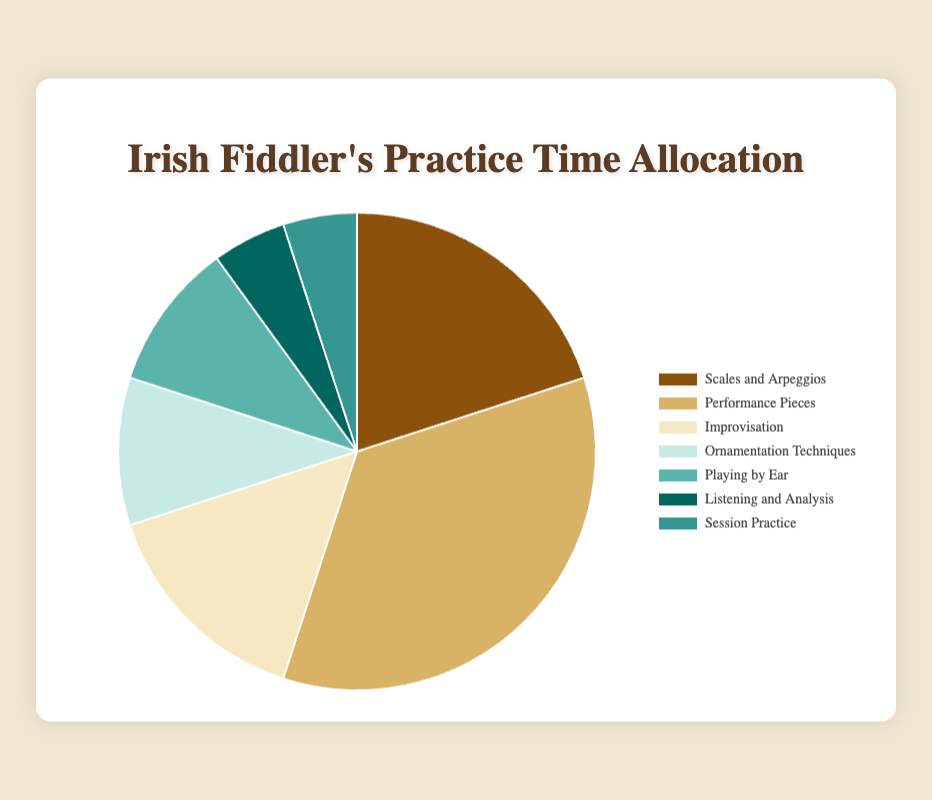What percentage of practice time is allocated to "Improvisation" and "Ornamentation Techniques" combined? To find the combined practice time, add the percentage allocated to "Improvisation" (15%) and "Ornamentation Techniques" (10%). This is 15% + 10% = 25%.
Answer: 25% Which component has the highest allocation of practice time? Look at the percentages for each component and identify the one with the highest value. "Performance Pieces" has the highest allocation at 35%.
Answer: Performance Pieces Is the practice time allocated to "Improvisation" more than that allocated to "Ornamentation Techniques"? Compare the percentages for "Improvisation" (15%) and "Ornamentation Techniques" (10%). Since 15% is greater than 10%, "Improvisation" has more practice time.
Answer: Yes What is the difference in practice time between "Scales and Arpeggios" and "Performance Pieces"? Subtract the percentage for "Scales and Arpeggios" (20%) from that for "Performance Pieces" (35%). This is 35% - 20% = 15%.
Answer: 15% Which components make up a total of 30% of practice time? Find combinations of components that add up to 30%. "Ornamentation Techniques" (10%), "Playing by Ear" (10%), and "Listening and Analysis" (5%) together add up to 30%. Alternatively, "Ornamentation Techniques" (10%) and "Improvisation" (15%) also sum to 30%.
Answer: Ornamentation Techniques, Playing by Ear, Listening and Analysis OR Ornamentation Techniques, Improvisation How much more practice time is allocated to "Playing by Ear" compared to "Listening and Analysis"? Subtract the percentage for "Listening and Analysis" (5%) from that for "Playing by Ear" (10%). This is 10% - 5% = 5%.
Answer: 5% What are the colors representing "Improvisation" and "Session Practice" on the pie chart? Based on the given data, "Improvisation" is represented by a certain color, and "Session Practice" by another. From the script, "Improvisation" is in a certain color, and "Session Practice" is in another. Describe the colors listed next to each.
Answer: Improvisation is light greenish-blue, Session Practice is teal If 50% of the total practice time must be spent on "Scales and Arpeggios" and "Performance Pieces", how much more time needs to be allocated to these components? Currently, "Scales and Arpeggios" (20%) and "Performance Pieces" (35%) together sum to 55%. Therefore, no additional time needs to be allocated as the combined total already exceeds 50%.
Answer: None; already exceeds 50% How does the time allocated to "Listening and Analysis" compare to "Session Practice"? Both "Listening and Analysis" and "Session Practice" are allocated the same percentage of practice time, 5%.
Answer: Equal What is the total percentage of time allocated to activities other than "Performance Pieces"? To find the total, add the percentages for all other components: "Scales and Arpeggios" (20%) + "Improvisation" (15%) + "Ornamentation Techniques" (10%) + "Playing by Ear" (10%) + "Listening and Analysis" (5%) + "Session Practice" (5%). This sum is 20% + 15% + 10% + 10% + 5% + 5% = 65%.
Answer: 65% 